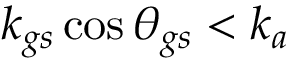Convert formula to latex. <formula><loc_0><loc_0><loc_500><loc_500>k _ { g s } \cos { \theta _ { g s } } < k _ { a }</formula> 